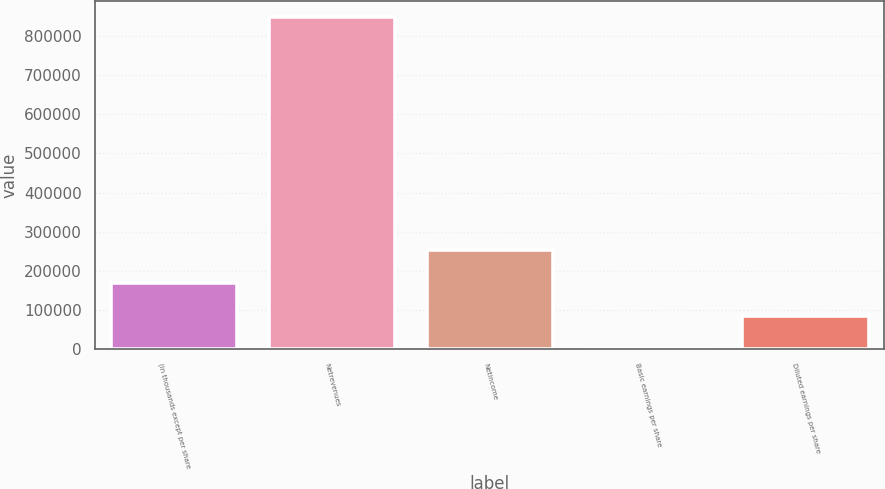Convert chart. <chart><loc_0><loc_0><loc_500><loc_500><bar_chart><fcel>(in thousands except per share<fcel>Netrevenues<fcel>Netincome<fcel>Basic earnings per share<fcel>Diluted earnings per share<nl><fcel>169610<fcel>848051<fcel>254415<fcel>0.05<fcel>84805.1<nl></chart> 